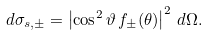Convert formula to latex. <formula><loc_0><loc_0><loc_500><loc_500>d \sigma _ { s , \pm } = \left | \cos ^ { 2 } \vartheta \, f _ { \pm } ( \theta ) \right | ^ { 2 } \, d \Omega .</formula> 